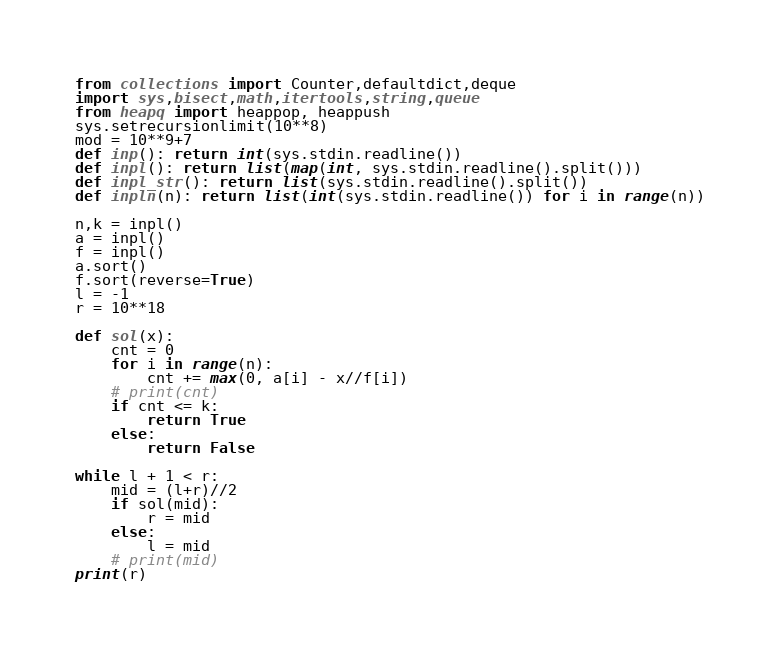<code> <loc_0><loc_0><loc_500><loc_500><_Python_>from collections import Counter,defaultdict,deque
import sys,bisect,math,itertools,string,queue
from heapq import heappop, heappush
sys.setrecursionlimit(10**8)
mod = 10**9+7
def inp(): return int(sys.stdin.readline())
def inpl(): return list(map(int, sys.stdin.readline().split()))
def inpl_str(): return list(sys.stdin.readline().split())
def inpln(n): return list(int(sys.stdin.readline()) for i in range(n))

n,k = inpl()
a = inpl()
f = inpl()
a.sort()
f.sort(reverse=True)
l = -1
r = 10**18

def sol(x):
    cnt = 0
    for i in range(n):
        cnt += max(0, a[i] - x//f[i])
    # print(cnt)
    if cnt <= k:
        return True
    else:
        return False

while l + 1 < r:
    mid = (l+r)//2
    if sol(mid):
        r = mid
    else:
        l = mid
    # print(mid)
print(r)



</code> 